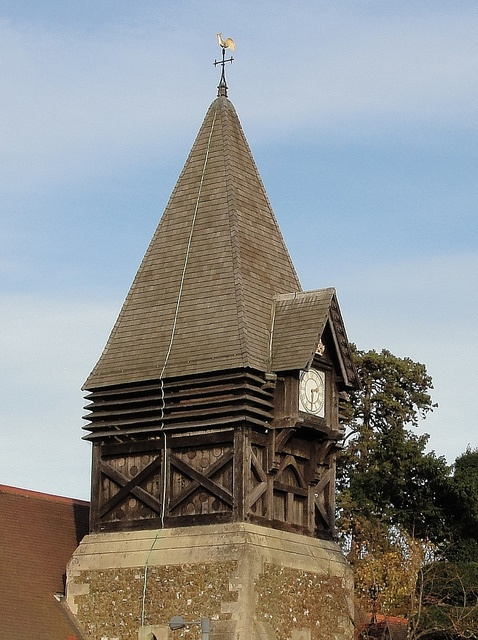Describe the objects in this image and their specific colors. I can see a clock in lightblue, beige, darkgray, and gray tones in this image. 